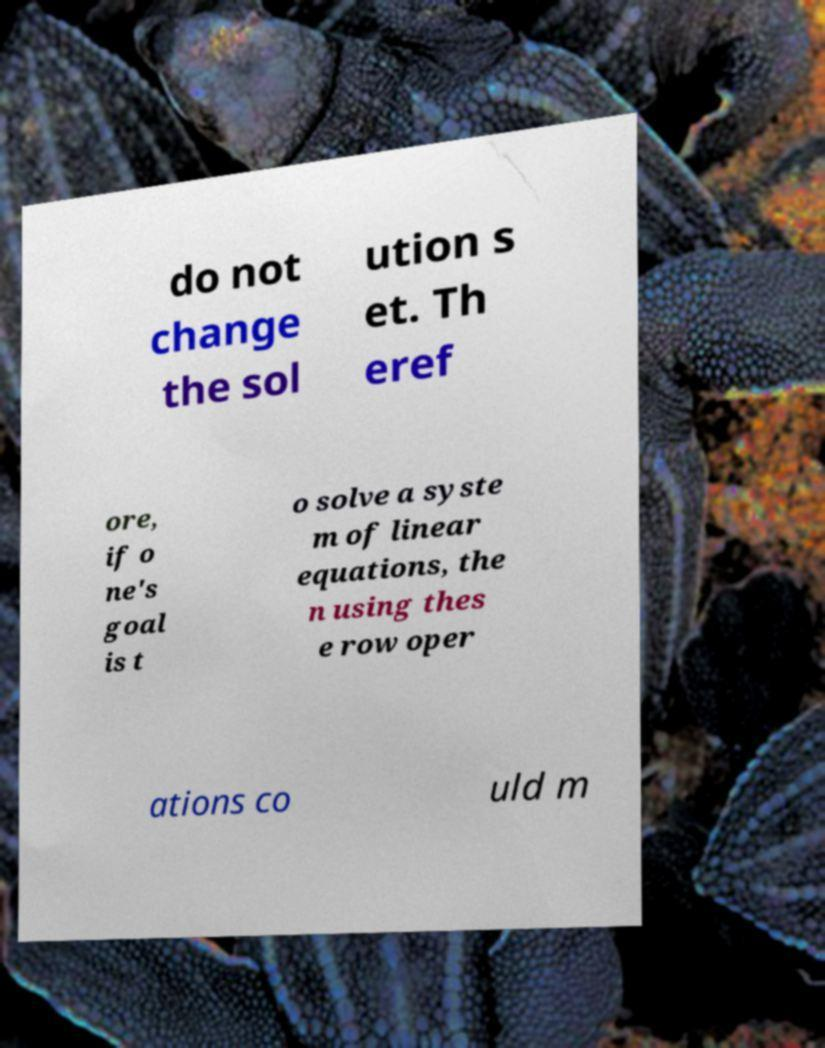For documentation purposes, I need the text within this image transcribed. Could you provide that? do not change the sol ution s et. Th eref ore, if o ne's goal is t o solve a syste m of linear equations, the n using thes e row oper ations co uld m 